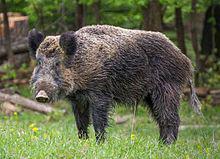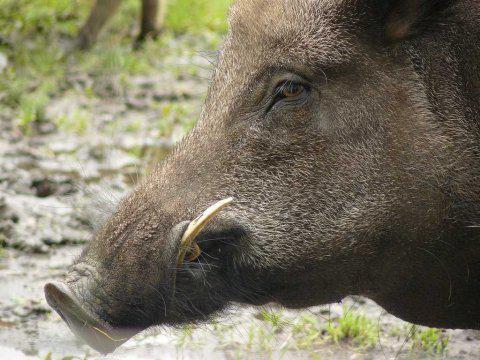The first image is the image on the left, the second image is the image on the right. For the images displayed, is the sentence "The left image shows only an adult boar, which is facing leftward." factually correct? Answer yes or no. Yes. The first image is the image on the left, the second image is the image on the right. Assess this claim about the two images: "The hog on the right image is standing and facing right". Correct or not? Answer yes or no. No. 